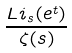<formula> <loc_0><loc_0><loc_500><loc_500>\frac { L i _ { s } ( e ^ { t } ) } { \zeta ( s ) }</formula> 